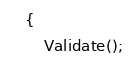<code> <loc_0><loc_0><loc_500><loc_500><_ObjectiveC_>    {
        Validate();</code> 